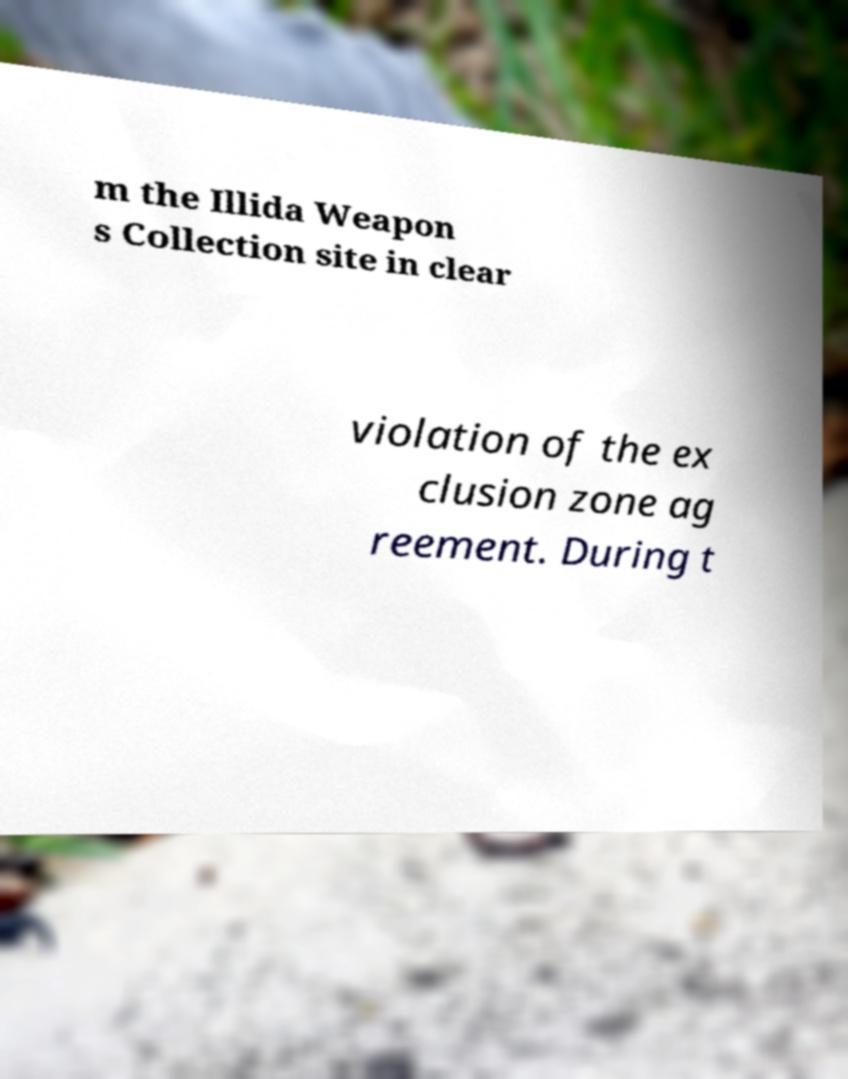Can you read and provide the text displayed in the image?This photo seems to have some interesting text. Can you extract and type it out for me? m the Illida Weapon s Collection site in clear violation of the ex clusion zone ag reement. During t 